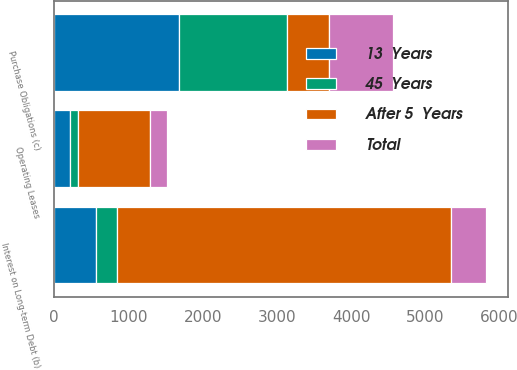Convert chart. <chart><loc_0><loc_0><loc_500><loc_500><stacked_bar_chart><ecel><fcel>Interest on Long-term Debt (b)<fcel>Operating Leases<fcel>Purchase Obligations (c)<nl><fcel>After 5  Years<fcel>4497<fcel>968<fcel>558<nl><fcel>45  Years<fcel>291<fcel>108<fcel>1459<nl><fcel>13  Years<fcel>558<fcel>216<fcel>1680<nl><fcel>Total<fcel>477<fcel>223<fcel>867<nl></chart> 